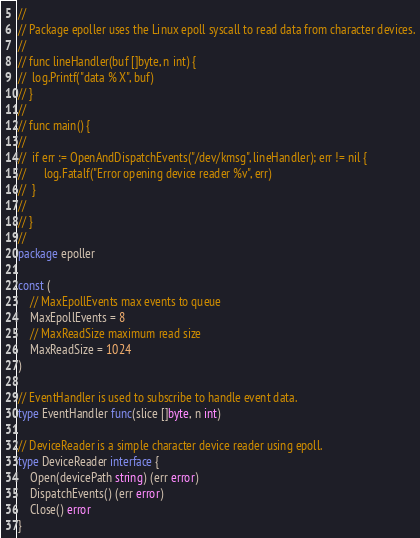Convert code to text. <code><loc_0><loc_0><loc_500><loc_500><_Go_>//
// Package epoller uses the Linux epoll syscall to read data from character devices.
//
// func lineHandler(buf []byte, n int) {
// 	log.Printf("data % X", buf)
// }
//
// func main() {
//
// 	if err := OpenAndDispatchEvents("/dev/kmsg", lineHandler); err != nil {
// 		log.Fatalf("Error opening device reader %v", err)
// 	}
//
// }
//
package epoller

const (
	// MaxEpollEvents max events to queue
	MaxEpollEvents = 8
	// MaxReadSize maximum read size
	MaxReadSize = 1024
)

// EventHandler is used to subscribe to handle event data.
type EventHandler func(slice []byte, n int)

// DeviceReader is a simple character device reader using epoll.
type DeviceReader interface {
	Open(devicePath string) (err error)
	DispatchEvents() (err error)
	Close() error
}
</code> 